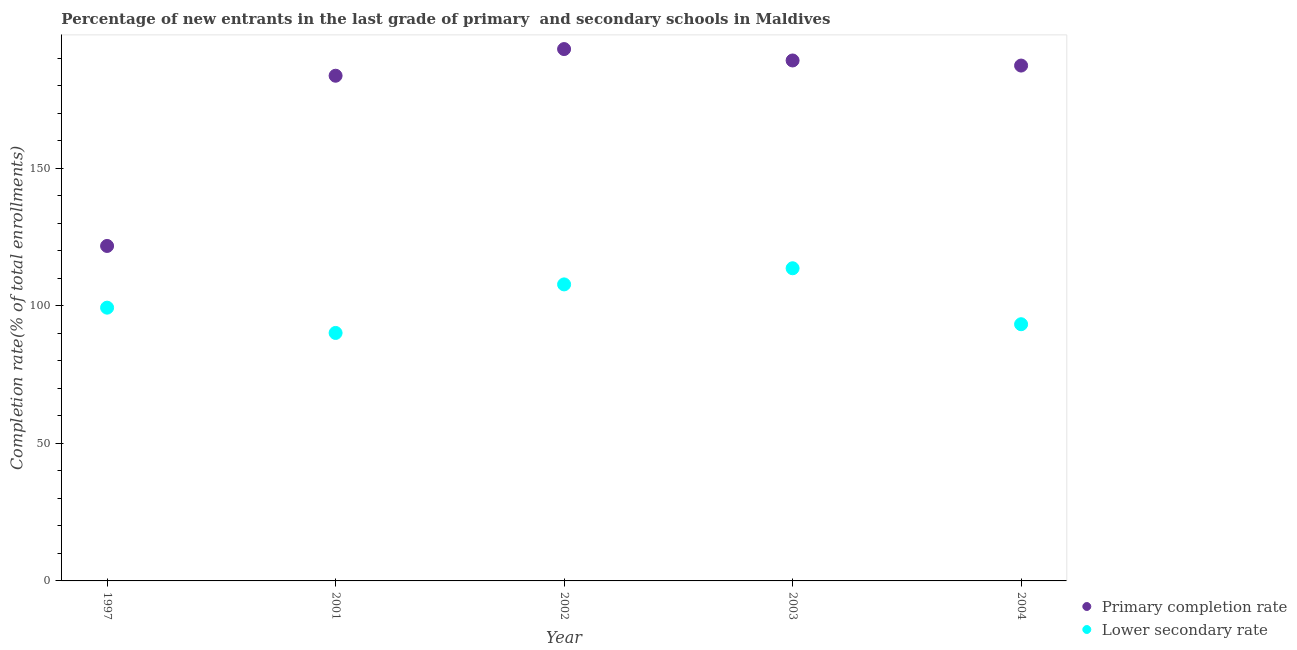Is the number of dotlines equal to the number of legend labels?
Give a very brief answer. Yes. What is the completion rate in primary schools in 2002?
Provide a short and direct response. 193.26. Across all years, what is the maximum completion rate in primary schools?
Your response must be concise. 193.26. Across all years, what is the minimum completion rate in primary schools?
Your answer should be very brief. 121.72. What is the total completion rate in secondary schools in the graph?
Offer a terse response. 504.04. What is the difference between the completion rate in primary schools in 2001 and that in 2002?
Provide a succinct answer. -9.69. What is the difference between the completion rate in primary schools in 1997 and the completion rate in secondary schools in 2002?
Offer a terse response. 13.97. What is the average completion rate in primary schools per year?
Offer a very short reply. 174.99. In the year 2003, what is the difference between the completion rate in primary schools and completion rate in secondary schools?
Provide a succinct answer. 75.51. What is the ratio of the completion rate in primary schools in 2001 to that in 2004?
Your answer should be compact. 0.98. Is the difference between the completion rate in primary schools in 2002 and 2004 greater than the difference between the completion rate in secondary schools in 2002 and 2004?
Provide a short and direct response. No. What is the difference between the highest and the second highest completion rate in secondary schools?
Make the answer very short. 5.86. What is the difference between the highest and the lowest completion rate in primary schools?
Provide a succinct answer. 71.54. Does the completion rate in secondary schools monotonically increase over the years?
Provide a short and direct response. No. Is the completion rate in primary schools strictly less than the completion rate in secondary schools over the years?
Offer a very short reply. No. How many dotlines are there?
Offer a terse response. 2. How many years are there in the graph?
Your response must be concise. 5. What is the difference between two consecutive major ticks on the Y-axis?
Your answer should be compact. 50. Are the values on the major ticks of Y-axis written in scientific E-notation?
Give a very brief answer. No. Does the graph contain any zero values?
Provide a succinct answer. No. Does the graph contain grids?
Keep it short and to the point. No. Where does the legend appear in the graph?
Provide a short and direct response. Bottom right. How are the legend labels stacked?
Offer a terse response. Vertical. What is the title of the graph?
Give a very brief answer. Percentage of new entrants in the last grade of primary  and secondary schools in Maldives. Does "By country of origin" appear as one of the legend labels in the graph?
Keep it short and to the point. No. What is the label or title of the X-axis?
Your answer should be very brief. Year. What is the label or title of the Y-axis?
Keep it short and to the point. Completion rate(% of total enrollments). What is the Completion rate(% of total enrollments) of Primary completion rate in 1997?
Your response must be concise. 121.72. What is the Completion rate(% of total enrollments) of Lower secondary rate in 1997?
Provide a short and direct response. 99.3. What is the Completion rate(% of total enrollments) in Primary completion rate in 2001?
Give a very brief answer. 183.57. What is the Completion rate(% of total enrollments) in Lower secondary rate in 2001?
Keep it short and to the point. 90.11. What is the Completion rate(% of total enrollments) in Primary completion rate in 2002?
Keep it short and to the point. 193.26. What is the Completion rate(% of total enrollments) of Lower secondary rate in 2002?
Make the answer very short. 107.75. What is the Completion rate(% of total enrollments) in Primary completion rate in 2003?
Your response must be concise. 189.12. What is the Completion rate(% of total enrollments) of Lower secondary rate in 2003?
Provide a short and direct response. 113.61. What is the Completion rate(% of total enrollments) of Primary completion rate in 2004?
Offer a very short reply. 187.27. What is the Completion rate(% of total enrollments) of Lower secondary rate in 2004?
Offer a terse response. 93.28. Across all years, what is the maximum Completion rate(% of total enrollments) of Primary completion rate?
Offer a very short reply. 193.26. Across all years, what is the maximum Completion rate(% of total enrollments) in Lower secondary rate?
Provide a short and direct response. 113.61. Across all years, what is the minimum Completion rate(% of total enrollments) of Primary completion rate?
Make the answer very short. 121.72. Across all years, what is the minimum Completion rate(% of total enrollments) of Lower secondary rate?
Keep it short and to the point. 90.11. What is the total Completion rate(% of total enrollments) in Primary completion rate in the graph?
Your response must be concise. 874.94. What is the total Completion rate(% of total enrollments) of Lower secondary rate in the graph?
Make the answer very short. 504.04. What is the difference between the Completion rate(% of total enrollments) in Primary completion rate in 1997 and that in 2001?
Ensure brevity in your answer.  -61.85. What is the difference between the Completion rate(% of total enrollments) of Lower secondary rate in 1997 and that in 2001?
Offer a terse response. 9.19. What is the difference between the Completion rate(% of total enrollments) in Primary completion rate in 1997 and that in 2002?
Give a very brief answer. -71.54. What is the difference between the Completion rate(% of total enrollments) of Lower secondary rate in 1997 and that in 2002?
Your answer should be very brief. -8.45. What is the difference between the Completion rate(% of total enrollments) in Primary completion rate in 1997 and that in 2003?
Your answer should be compact. -67.4. What is the difference between the Completion rate(% of total enrollments) of Lower secondary rate in 1997 and that in 2003?
Ensure brevity in your answer.  -14.32. What is the difference between the Completion rate(% of total enrollments) of Primary completion rate in 1997 and that in 2004?
Make the answer very short. -65.55. What is the difference between the Completion rate(% of total enrollments) of Lower secondary rate in 1997 and that in 2004?
Keep it short and to the point. 6.02. What is the difference between the Completion rate(% of total enrollments) in Primary completion rate in 2001 and that in 2002?
Give a very brief answer. -9.69. What is the difference between the Completion rate(% of total enrollments) of Lower secondary rate in 2001 and that in 2002?
Provide a short and direct response. -17.64. What is the difference between the Completion rate(% of total enrollments) in Primary completion rate in 2001 and that in 2003?
Your answer should be compact. -5.54. What is the difference between the Completion rate(% of total enrollments) of Lower secondary rate in 2001 and that in 2003?
Keep it short and to the point. -23.51. What is the difference between the Completion rate(% of total enrollments) of Primary completion rate in 2001 and that in 2004?
Provide a succinct answer. -3.69. What is the difference between the Completion rate(% of total enrollments) of Lower secondary rate in 2001 and that in 2004?
Ensure brevity in your answer.  -3.17. What is the difference between the Completion rate(% of total enrollments) of Primary completion rate in 2002 and that in 2003?
Your answer should be compact. 4.15. What is the difference between the Completion rate(% of total enrollments) in Lower secondary rate in 2002 and that in 2003?
Your response must be concise. -5.86. What is the difference between the Completion rate(% of total enrollments) in Primary completion rate in 2002 and that in 2004?
Offer a very short reply. 5.99. What is the difference between the Completion rate(% of total enrollments) of Lower secondary rate in 2002 and that in 2004?
Your answer should be compact. 14.47. What is the difference between the Completion rate(% of total enrollments) in Primary completion rate in 2003 and that in 2004?
Make the answer very short. 1.85. What is the difference between the Completion rate(% of total enrollments) of Lower secondary rate in 2003 and that in 2004?
Offer a terse response. 20.33. What is the difference between the Completion rate(% of total enrollments) in Primary completion rate in 1997 and the Completion rate(% of total enrollments) in Lower secondary rate in 2001?
Your response must be concise. 31.61. What is the difference between the Completion rate(% of total enrollments) in Primary completion rate in 1997 and the Completion rate(% of total enrollments) in Lower secondary rate in 2002?
Keep it short and to the point. 13.97. What is the difference between the Completion rate(% of total enrollments) of Primary completion rate in 1997 and the Completion rate(% of total enrollments) of Lower secondary rate in 2003?
Your answer should be compact. 8.11. What is the difference between the Completion rate(% of total enrollments) of Primary completion rate in 1997 and the Completion rate(% of total enrollments) of Lower secondary rate in 2004?
Provide a short and direct response. 28.44. What is the difference between the Completion rate(% of total enrollments) in Primary completion rate in 2001 and the Completion rate(% of total enrollments) in Lower secondary rate in 2002?
Your answer should be compact. 75.83. What is the difference between the Completion rate(% of total enrollments) in Primary completion rate in 2001 and the Completion rate(% of total enrollments) in Lower secondary rate in 2003?
Your response must be concise. 69.96. What is the difference between the Completion rate(% of total enrollments) in Primary completion rate in 2001 and the Completion rate(% of total enrollments) in Lower secondary rate in 2004?
Offer a very short reply. 90.3. What is the difference between the Completion rate(% of total enrollments) of Primary completion rate in 2002 and the Completion rate(% of total enrollments) of Lower secondary rate in 2003?
Give a very brief answer. 79.65. What is the difference between the Completion rate(% of total enrollments) of Primary completion rate in 2002 and the Completion rate(% of total enrollments) of Lower secondary rate in 2004?
Ensure brevity in your answer.  99.99. What is the difference between the Completion rate(% of total enrollments) in Primary completion rate in 2003 and the Completion rate(% of total enrollments) in Lower secondary rate in 2004?
Give a very brief answer. 95.84. What is the average Completion rate(% of total enrollments) in Primary completion rate per year?
Offer a very short reply. 174.99. What is the average Completion rate(% of total enrollments) of Lower secondary rate per year?
Keep it short and to the point. 100.81. In the year 1997, what is the difference between the Completion rate(% of total enrollments) in Primary completion rate and Completion rate(% of total enrollments) in Lower secondary rate?
Ensure brevity in your answer.  22.42. In the year 2001, what is the difference between the Completion rate(% of total enrollments) of Primary completion rate and Completion rate(% of total enrollments) of Lower secondary rate?
Ensure brevity in your answer.  93.47. In the year 2002, what is the difference between the Completion rate(% of total enrollments) in Primary completion rate and Completion rate(% of total enrollments) in Lower secondary rate?
Offer a very short reply. 85.52. In the year 2003, what is the difference between the Completion rate(% of total enrollments) of Primary completion rate and Completion rate(% of total enrollments) of Lower secondary rate?
Provide a succinct answer. 75.51. In the year 2004, what is the difference between the Completion rate(% of total enrollments) in Primary completion rate and Completion rate(% of total enrollments) in Lower secondary rate?
Ensure brevity in your answer.  93.99. What is the ratio of the Completion rate(% of total enrollments) in Primary completion rate in 1997 to that in 2001?
Provide a succinct answer. 0.66. What is the ratio of the Completion rate(% of total enrollments) of Lower secondary rate in 1997 to that in 2001?
Offer a very short reply. 1.1. What is the ratio of the Completion rate(% of total enrollments) in Primary completion rate in 1997 to that in 2002?
Give a very brief answer. 0.63. What is the ratio of the Completion rate(% of total enrollments) in Lower secondary rate in 1997 to that in 2002?
Give a very brief answer. 0.92. What is the ratio of the Completion rate(% of total enrollments) in Primary completion rate in 1997 to that in 2003?
Provide a succinct answer. 0.64. What is the ratio of the Completion rate(% of total enrollments) in Lower secondary rate in 1997 to that in 2003?
Your response must be concise. 0.87. What is the ratio of the Completion rate(% of total enrollments) in Primary completion rate in 1997 to that in 2004?
Provide a short and direct response. 0.65. What is the ratio of the Completion rate(% of total enrollments) of Lower secondary rate in 1997 to that in 2004?
Give a very brief answer. 1.06. What is the ratio of the Completion rate(% of total enrollments) in Primary completion rate in 2001 to that in 2002?
Your answer should be very brief. 0.95. What is the ratio of the Completion rate(% of total enrollments) in Lower secondary rate in 2001 to that in 2002?
Provide a succinct answer. 0.84. What is the ratio of the Completion rate(% of total enrollments) of Primary completion rate in 2001 to that in 2003?
Provide a short and direct response. 0.97. What is the ratio of the Completion rate(% of total enrollments) of Lower secondary rate in 2001 to that in 2003?
Provide a succinct answer. 0.79. What is the ratio of the Completion rate(% of total enrollments) of Primary completion rate in 2001 to that in 2004?
Keep it short and to the point. 0.98. What is the ratio of the Completion rate(% of total enrollments) in Primary completion rate in 2002 to that in 2003?
Provide a short and direct response. 1.02. What is the ratio of the Completion rate(% of total enrollments) in Lower secondary rate in 2002 to that in 2003?
Your answer should be compact. 0.95. What is the ratio of the Completion rate(% of total enrollments) in Primary completion rate in 2002 to that in 2004?
Your answer should be compact. 1.03. What is the ratio of the Completion rate(% of total enrollments) of Lower secondary rate in 2002 to that in 2004?
Your answer should be very brief. 1.16. What is the ratio of the Completion rate(% of total enrollments) of Primary completion rate in 2003 to that in 2004?
Provide a succinct answer. 1.01. What is the ratio of the Completion rate(% of total enrollments) of Lower secondary rate in 2003 to that in 2004?
Provide a succinct answer. 1.22. What is the difference between the highest and the second highest Completion rate(% of total enrollments) of Primary completion rate?
Make the answer very short. 4.15. What is the difference between the highest and the second highest Completion rate(% of total enrollments) in Lower secondary rate?
Keep it short and to the point. 5.86. What is the difference between the highest and the lowest Completion rate(% of total enrollments) in Primary completion rate?
Provide a succinct answer. 71.54. What is the difference between the highest and the lowest Completion rate(% of total enrollments) of Lower secondary rate?
Your answer should be compact. 23.51. 